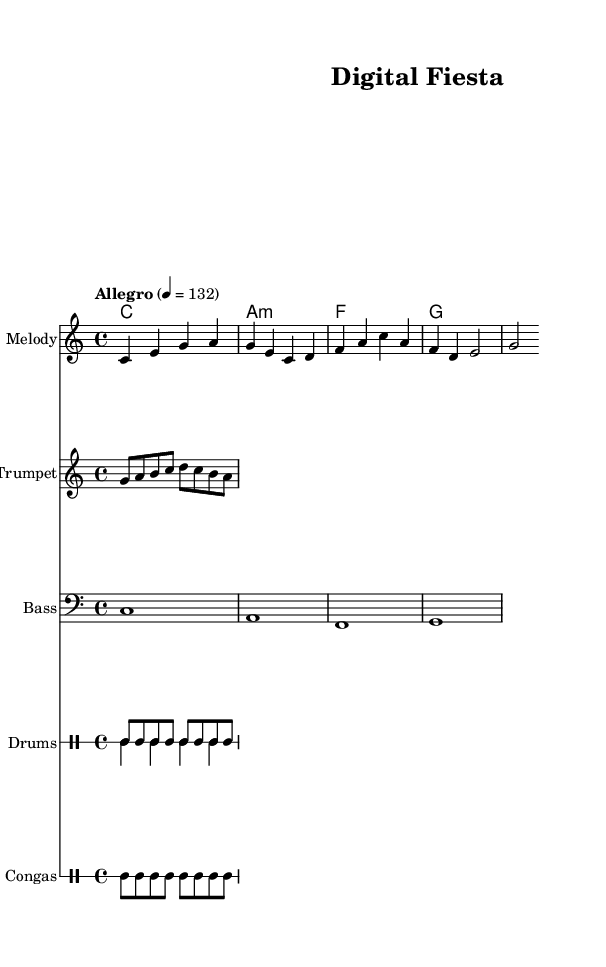What is the key signature of this music? The key signature is indicated at the beginning of the score. In this piece, it is C major, which shows no sharps or flats.
Answer: C major What is the time signature of this piece? The time signature is shown at the start of the score. Here, it is 4/4, which means there are four beats in a measure.
Answer: 4/4 What is the tempo marking for this music? The tempo is indicated under the global settings of the score. The marking "Allegro" along with "4 = 132" suggests a quick pace.
Answer: Allegro How many measures are in the melody section? To find the number of measures, we count the number of vertical bar lines in the melody staff. There are four measures in total.
Answer: 4 What primary instruments are featured in this composition? The score includes several staffs mentioning specific instruments. The melody, trumpet, bass, drums, and congas are all present.
Answer: Melody, Trumpet, Bass, Drums, Congas What is the primary theme of the lyrics provided? The lyrics mention "Digital revolution" and "innovation," suggesting a focus on change and progress through technology. This context aligns with the upbeat Latin pop genre.
Answer: Digital innovation 